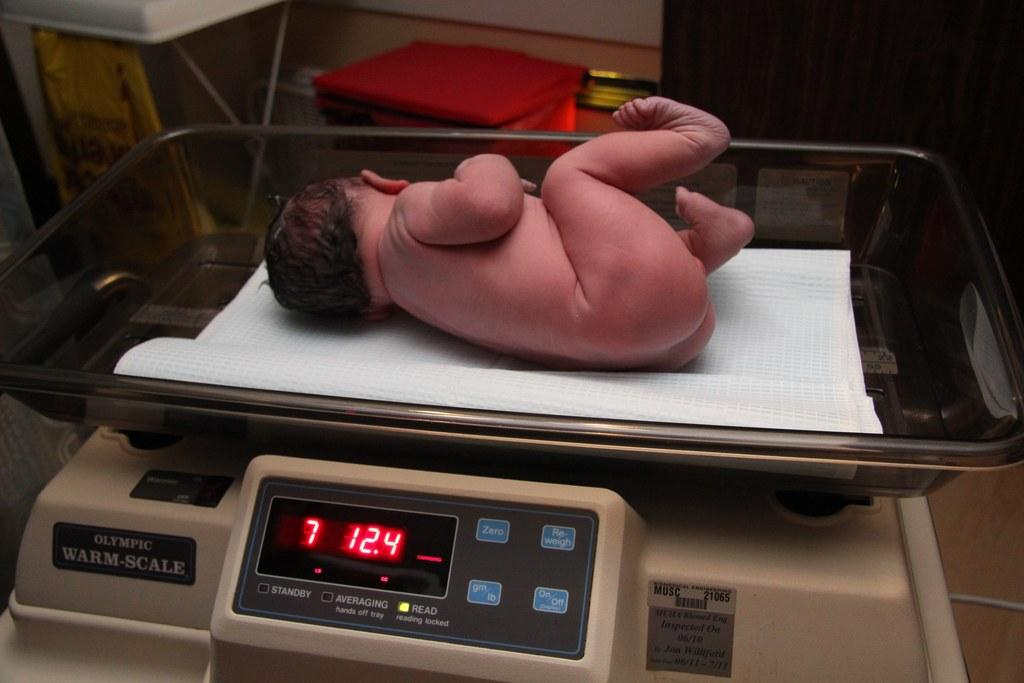What is the main subject of the image? There is a baby in the image. Where is the baby positioned in the image? The baby is lying in a measuring tray on a machine. What can be seen in the background of the image? There is a table, a wall, and a curtain in the background of the image. What type of setting is suggested by the background elements? The image is likely taken in a room, as indicated by the presence of a table, wall, and curtain. What type of jelly is being used to measure the baby's weight in the image? There is no jelly present in the image; the baby is lying in a measuring tray on a machine. How many springs are visible in the image? There are no springs visible in the image. 